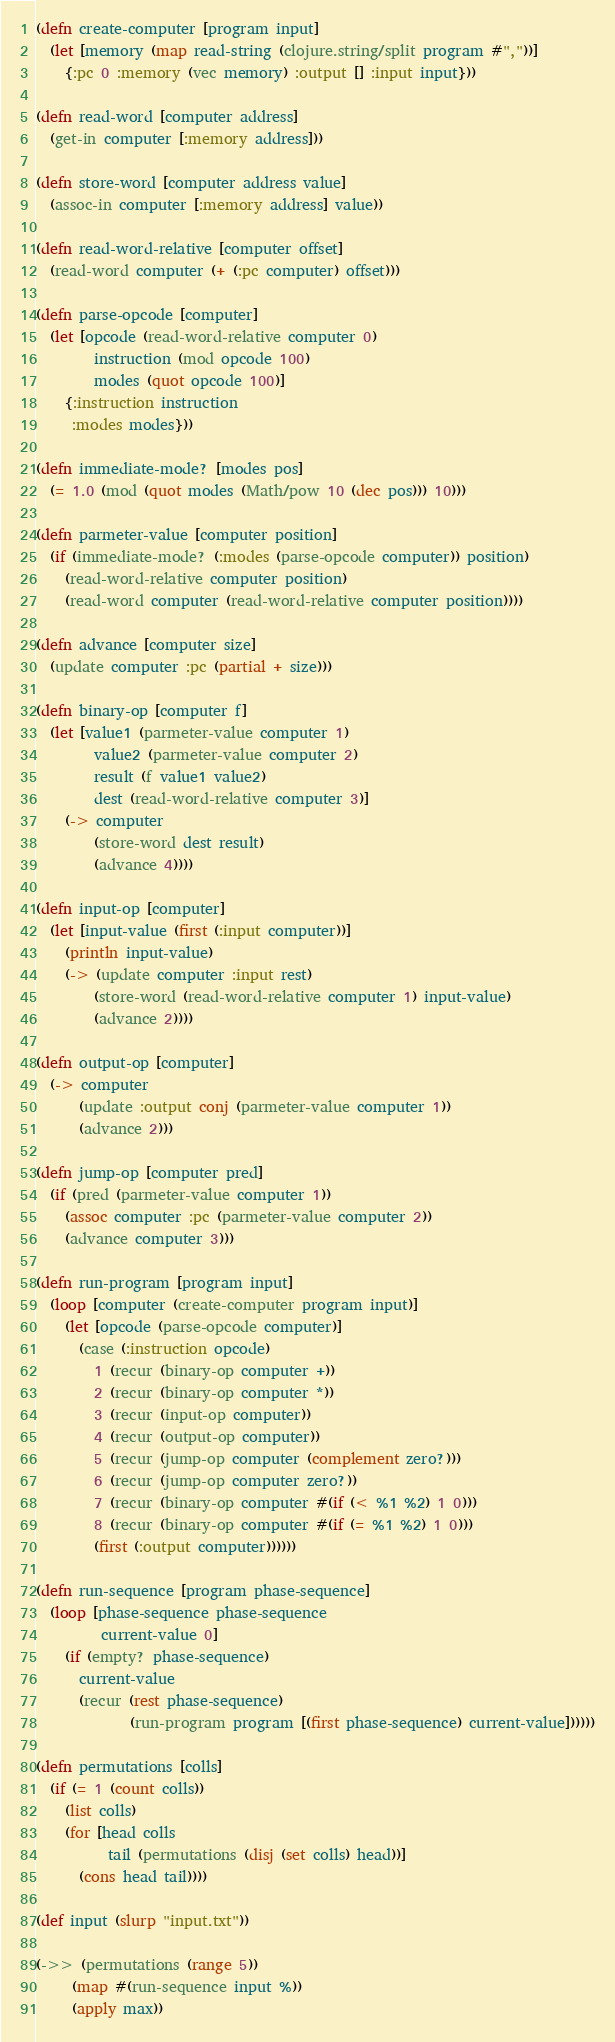<code> <loc_0><loc_0><loc_500><loc_500><_Clojure_>(defn create-computer [program input]
  (let [memory (map read-string (clojure.string/split program #","))]
    {:pc 0 :memory (vec memory) :output [] :input input}))

(defn read-word [computer address]
  (get-in computer [:memory address]))

(defn store-word [computer address value]
  (assoc-in computer [:memory address] value))

(defn read-word-relative [computer offset]
  (read-word computer (+ (:pc computer) offset)))

(defn parse-opcode [computer]
  (let [opcode (read-word-relative computer 0)
        instruction (mod opcode 100)
        modes (quot opcode 100)]
    {:instruction instruction
     :modes modes}))

(defn immediate-mode? [modes pos]
  (= 1.0 (mod (quot modes (Math/pow 10 (dec pos))) 10)))

(defn parmeter-value [computer position]
  (if (immediate-mode? (:modes (parse-opcode computer)) position)
    (read-word-relative computer position)
    (read-word computer (read-word-relative computer position))))

(defn advance [computer size]
  (update computer :pc (partial + size)))

(defn binary-op [computer f]
  (let [value1 (parmeter-value computer 1)
        value2 (parmeter-value computer 2)
        result (f value1 value2)
        dest (read-word-relative computer 3)]
    (-> computer
        (store-word dest result)
        (advance 4))))

(defn input-op [computer]
  (let [input-value (first (:input computer))]
    (println input-value)
    (-> (update computer :input rest)
        (store-word (read-word-relative computer 1) input-value)
        (advance 2))))

(defn output-op [computer]
  (-> computer
      (update :output conj (parmeter-value computer 1))
      (advance 2)))

(defn jump-op [computer pred]
  (if (pred (parmeter-value computer 1))
    (assoc computer :pc (parmeter-value computer 2))
    (advance computer 3)))

(defn run-program [program input]
  (loop [computer (create-computer program input)]
    (let [opcode (parse-opcode computer)]
      (case (:instruction opcode)
        1 (recur (binary-op computer +))
        2 (recur (binary-op computer *))
        3 (recur (input-op computer))
        4 (recur (output-op computer))
        5 (recur (jump-op computer (complement zero?)))
        6 (recur (jump-op computer zero?))
        7 (recur (binary-op computer #(if (< %1 %2) 1 0)))
        8 (recur (binary-op computer #(if (= %1 %2) 1 0)))
        (first (:output computer))))))

(defn run-sequence [program phase-sequence]
  (loop [phase-sequence phase-sequence
         current-value 0]
    (if (empty? phase-sequence)
      current-value
      (recur (rest phase-sequence) 
             (run-program program [(first phase-sequence) current-value])))))

(defn permutations [colls]
  (if (= 1 (count colls))
    (list colls)
    (for [head colls
          tail (permutations (disj (set colls) head))]
      (cons head tail))))

(def input (slurp "input.txt"))

(->> (permutations (range 5))
     (map #(run-sequence input %))
     (apply max))
</code> 